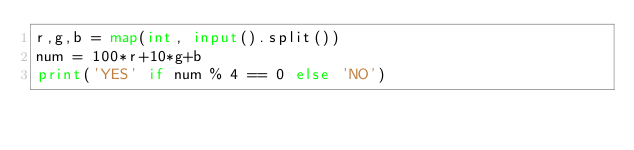<code> <loc_0><loc_0><loc_500><loc_500><_Python_>r,g,b = map(int, input().split())
num = 100*r+10*g+b
print('YES' if num % 4 == 0 else 'NO')</code> 